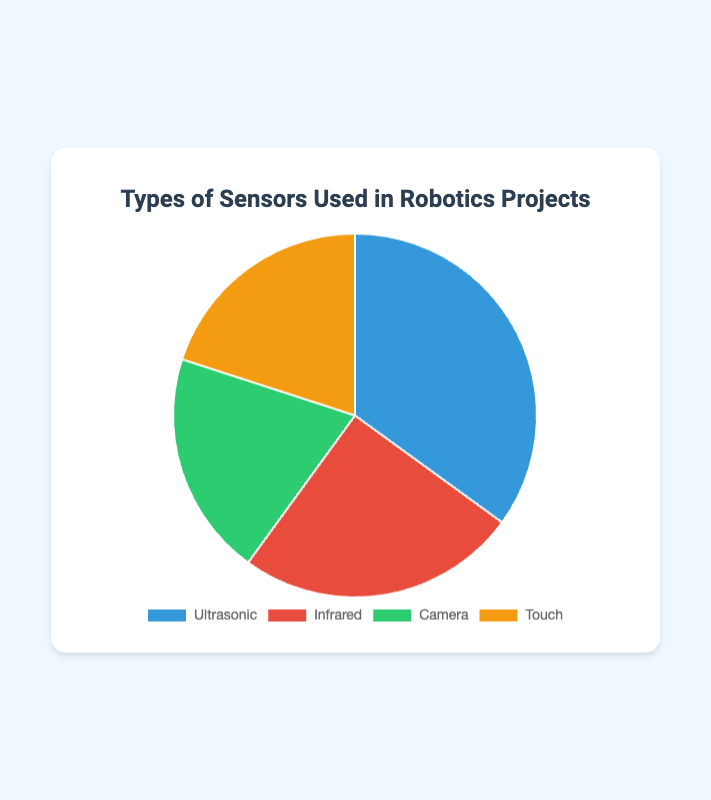What percentage of sensors used in robotics projects are Touch sensors? The Touch sensors constitute 20% of the total sensors used. This can be directly read from the figure, where Touch sensors are labeled with a 20% value.
Answer: 20% Which type of sensor is used the most in robotics projects? The figure shows that Ultrasonic sensors have the highest percentage at 35%. This is the largest slice in the pie chart.
Answer: Ultrasonic How many more percentage points do Ultrasonic sensors hold compared to Infrared sensors? Ultrasonic sensors are at 35% and Infrared sensors are at 25%. The difference is 35% - 25%.
Answer: 10% What is the combined percentage of Camera and Touch sensors? Camera sensors are at 20% and Touch sensors are also at 20%. Their combined percentage is 20% + 20%.
Answer: 40% Are there any sensors that are used equally in percentage terms? If so, which ones? The figure indicates that both Camera and Touch sensors have the same percentage of usage, each at 20%.
Answer: Camera and Touch Which sensor is represented by the blue color in the pie chart? The blue color in the pie chart corresponds to the Ultrasonic sensor, as seen from the color coding in the figure.
Answer: Ultrasonic If you wanted to replace all Ultrasonic sensors with Camera sensors, what would the new percentage of Camera sensors be? Currently, Ultrasonic sensors are 35% and Camera sensors are 20%. Replacing Ultrasonic sensors with Camera sensors adds 35% to the existing 20%.
Answer: 55% Which sensor type has the second-highest usage rate? The sensor with the second-highest usage rate is Infrared, which occupies 25% of the pie chart.
Answer: Infrared Which two sensors hold an equal percentage in the usage distribution? Both Camera and Touch sensors have an equal percentage of 20% each.
Answer: Camera and Touch 